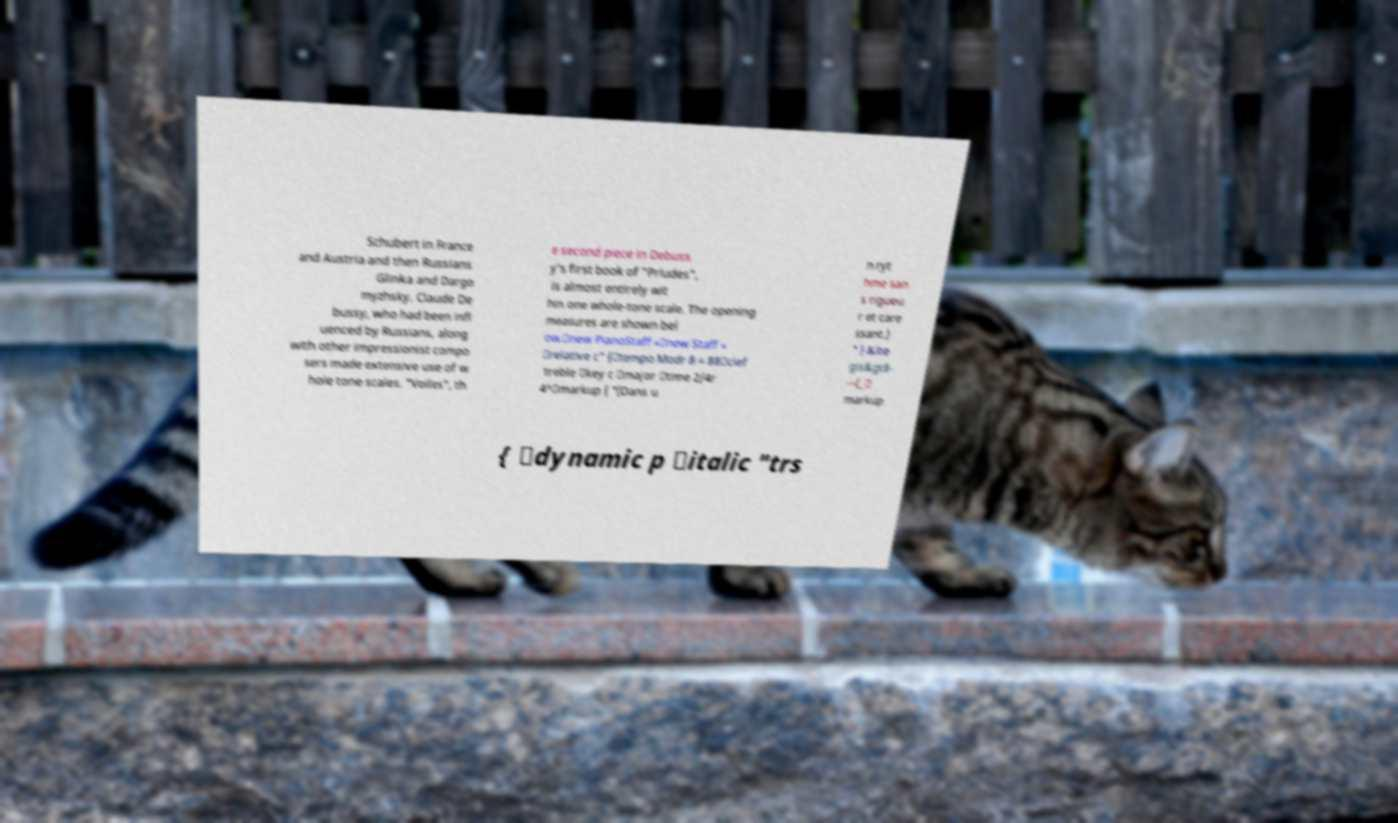What messages or text are displayed in this image? I need them in a readable, typed format. Schubert in France and Austria and then Russians Glinka and Dargo myzhsky. Claude De bussy, who had been infl uenced by Russians, along with other impressionist compo sers made extensive use of w hole tone scales. "Voiles", th e second piece in Debuss y's first book of "Prludes", is almost entirely wit hin one whole-tone scale. The opening measures are shown bel ow.\new PianoStaff «\new Staff « \relative c" {\tempo Modr 8 = 88\clef treble \key c \major \time 2/4r 4^\markup { "(Dans u n ryt hme san s rigueu r et care ssant.) " } &lte gis&gt8- -~(_\ markup { \dynamic p \italic "trs 